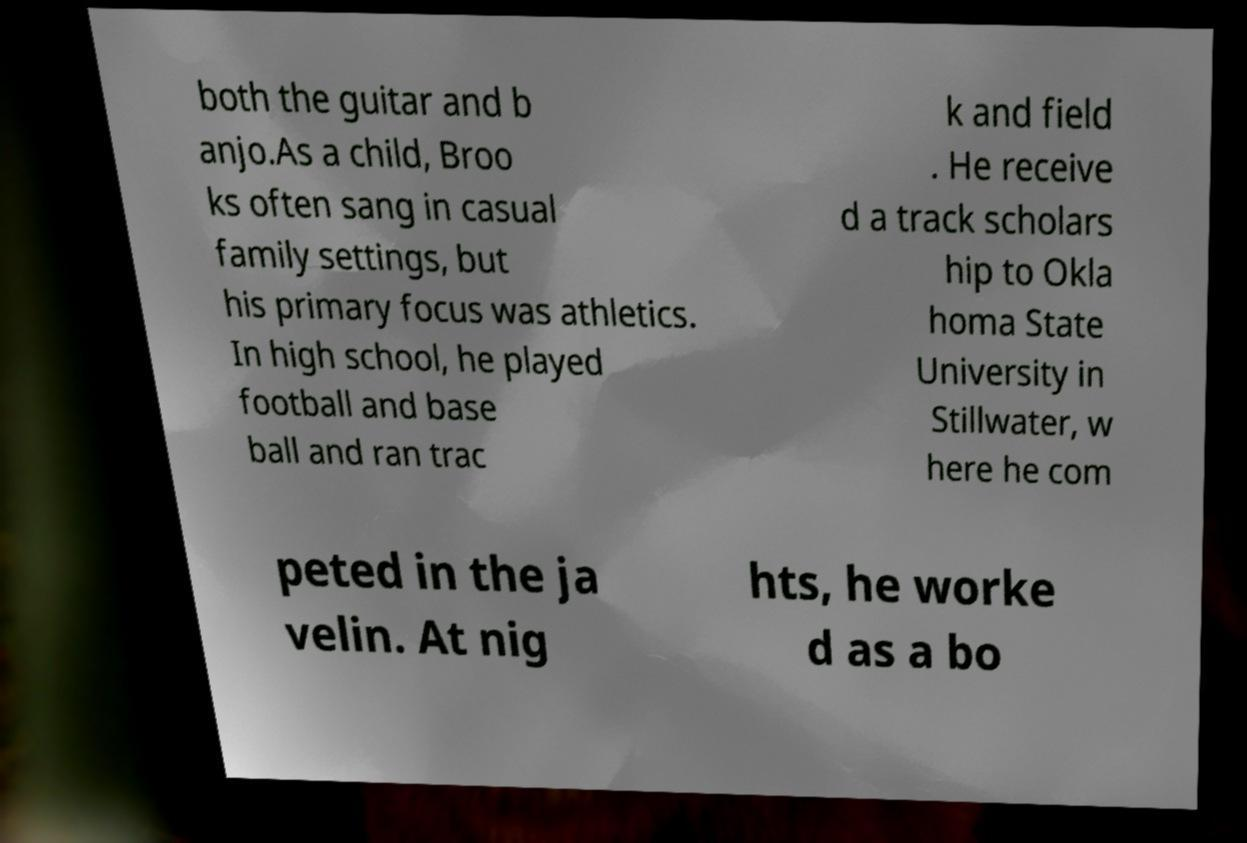There's text embedded in this image that I need extracted. Can you transcribe it verbatim? both the guitar and b anjo.As a child, Broo ks often sang in casual family settings, but his primary focus was athletics. In high school, he played football and base ball and ran trac k and field . He receive d a track scholars hip to Okla homa State University in Stillwater, w here he com peted in the ja velin. At nig hts, he worke d as a bo 